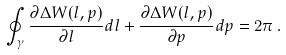<formula> <loc_0><loc_0><loc_500><loc_500>\oint _ { \gamma } \frac { \partial \Delta W ( l , p ) } { \partial l } d l + \frac { \partial \Delta W ( l , p ) } { \partial p } d p = 2 \pi \, .</formula> 